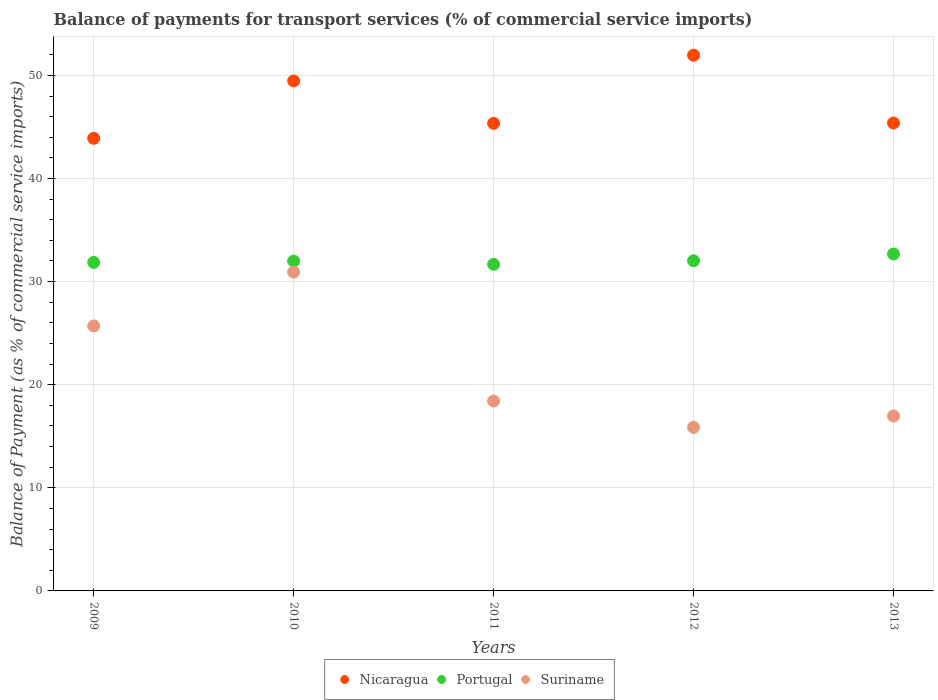What is the balance of payments for transport services in Portugal in 2013?
Provide a short and direct response. 32.68. Across all years, what is the maximum balance of payments for transport services in Suriname?
Your answer should be very brief. 30.92. Across all years, what is the minimum balance of payments for transport services in Portugal?
Your response must be concise. 31.68. In which year was the balance of payments for transport services in Portugal minimum?
Provide a succinct answer. 2011. What is the total balance of payments for transport services in Portugal in the graph?
Your answer should be very brief. 160.23. What is the difference between the balance of payments for transport services in Portugal in 2009 and that in 2012?
Offer a terse response. -0.16. What is the difference between the balance of payments for transport services in Portugal in 2010 and the balance of payments for transport services in Nicaragua in 2009?
Your response must be concise. -11.91. What is the average balance of payments for transport services in Portugal per year?
Your answer should be compact. 32.05. In the year 2013, what is the difference between the balance of payments for transport services in Portugal and balance of payments for transport services in Nicaragua?
Your answer should be compact. -12.7. What is the ratio of the balance of payments for transport services in Nicaragua in 2009 to that in 2013?
Offer a terse response. 0.97. Is the difference between the balance of payments for transport services in Portugal in 2012 and 2013 greater than the difference between the balance of payments for transport services in Nicaragua in 2012 and 2013?
Provide a short and direct response. No. What is the difference between the highest and the second highest balance of payments for transport services in Suriname?
Your response must be concise. 5.22. What is the difference between the highest and the lowest balance of payments for transport services in Portugal?
Offer a very short reply. 1. How many dotlines are there?
Provide a succinct answer. 3. Are the values on the major ticks of Y-axis written in scientific E-notation?
Give a very brief answer. No. Does the graph contain grids?
Ensure brevity in your answer.  Yes. Where does the legend appear in the graph?
Your answer should be compact. Bottom center. How many legend labels are there?
Give a very brief answer. 3. How are the legend labels stacked?
Provide a short and direct response. Horizontal. What is the title of the graph?
Provide a short and direct response. Balance of payments for transport services (% of commercial service imports). Does "Aruba" appear as one of the legend labels in the graph?
Make the answer very short. No. What is the label or title of the X-axis?
Make the answer very short. Years. What is the label or title of the Y-axis?
Your answer should be compact. Balance of Payment (as % of commercial service imports). What is the Balance of Payment (as % of commercial service imports) of Nicaragua in 2009?
Your answer should be very brief. 43.9. What is the Balance of Payment (as % of commercial service imports) of Portugal in 2009?
Ensure brevity in your answer.  31.86. What is the Balance of Payment (as % of commercial service imports) in Suriname in 2009?
Make the answer very short. 25.7. What is the Balance of Payment (as % of commercial service imports) in Nicaragua in 2010?
Keep it short and to the point. 49.46. What is the Balance of Payment (as % of commercial service imports) in Portugal in 2010?
Your response must be concise. 31.99. What is the Balance of Payment (as % of commercial service imports) of Suriname in 2010?
Make the answer very short. 30.92. What is the Balance of Payment (as % of commercial service imports) of Nicaragua in 2011?
Provide a succinct answer. 45.35. What is the Balance of Payment (as % of commercial service imports) in Portugal in 2011?
Your response must be concise. 31.68. What is the Balance of Payment (as % of commercial service imports) in Suriname in 2011?
Your answer should be compact. 18.42. What is the Balance of Payment (as % of commercial service imports) in Nicaragua in 2012?
Your answer should be very brief. 51.96. What is the Balance of Payment (as % of commercial service imports) in Portugal in 2012?
Ensure brevity in your answer.  32.02. What is the Balance of Payment (as % of commercial service imports) in Suriname in 2012?
Your response must be concise. 15.87. What is the Balance of Payment (as % of commercial service imports) of Nicaragua in 2013?
Provide a succinct answer. 45.38. What is the Balance of Payment (as % of commercial service imports) of Portugal in 2013?
Give a very brief answer. 32.68. What is the Balance of Payment (as % of commercial service imports) in Suriname in 2013?
Make the answer very short. 16.96. Across all years, what is the maximum Balance of Payment (as % of commercial service imports) of Nicaragua?
Ensure brevity in your answer.  51.96. Across all years, what is the maximum Balance of Payment (as % of commercial service imports) in Portugal?
Keep it short and to the point. 32.68. Across all years, what is the maximum Balance of Payment (as % of commercial service imports) in Suriname?
Keep it short and to the point. 30.92. Across all years, what is the minimum Balance of Payment (as % of commercial service imports) of Nicaragua?
Provide a succinct answer. 43.9. Across all years, what is the minimum Balance of Payment (as % of commercial service imports) in Portugal?
Keep it short and to the point. 31.68. Across all years, what is the minimum Balance of Payment (as % of commercial service imports) of Suriname?
Keep it short and to the point. 15.87. What is the total Balance of Payment (as % of commercial service imports) in Nicaragua in the graph?
Provide a succinct answer. 236.05. What is the total Balance of Payment (as % of commercial service imports) in Portugal in the graph?
Keep it short and to the point. 160.23. What is the total Balance of Payment (as % of commercial service imports) in Suriname in the graph?
Provide a succinct answer. 107.88. What is the difference between the Balance of Payment (as % of commercial service imports) in Nicaragua in 2009 and that in 2010?
Offer a very short reply. -5.57. What is the difference between the Balance of Payment (as % of commercial service imports) of Portugal in 2009 and that in 2010?
Give a very brief answer. -0.13. What is the difference between the Balance of Payment (as % of commercial service imports) of Suriname in 2009 and that in 2010?
Keep it short and to the point. -5.22. What is the difference between the Balance of Payment (as % of commercial service imports) of Nicaragua in 2009 and that in 2011?
Your response must be concise. -1.45. What is the difference between the Balance of Payment (as % of commercial service imports) of Portugal in 2009 and that in 2011?
Provide a succinct answer. 0.18. What is the difference between the Balance of Payment (as % of commercial service imports) of Suriname in 2009 and that in 2011?
Offer a terse response. 7.28. What is the difference between the Balance of Payment (as % of commercial service imports) of Nicaragua in 2009 and that in 2012?
Make the answer very short. -8.06. What is the difference between the Balance of Payment (as % of commercial service imports) in Portugal in 2009 and that in 2012?
Provide a short and direct response. -0.16. What is the difference between the Balance of Payment (as % of commercial service imports) in Suriname in 2009 and that in 2012?
Your answer should be very brief. 9.84. What is the difference between the Balance of Payment (as % of commercial service imports) of Nicaragua in 2009 and that in 2013?
Keep it short and to the point. -1.48. What is the difference between the Balance of Payment (as % of commercial service imports) of Portugal in 2009 and that in 2013?
Give a very brief answer. -0.82. What is the difference between the Balance of Payment (as % of commercial service imports) of Suriname in 2009 and that in 2013?
Give a very brief answer. 8.74. What is the difference between the Balance of Payment (as % of commercial service imports) in Nicaragua in 2010 and that in 2011?
Give a very brief answer. 4.11. What is the difference between the Balance of Payment (as % of commercial service imports) in Portugal in 2010 and that in 2011?
Offer a terse response. 0.31. What is the difference between the Balance of Payment (as % of commercial service imports) in Suriname in 2010 and that in 2011?
Ensure brevity in your answer.  12.5. What is the difference between the Balance of Payment (as % of commercial service imports) in Nicaragua in 2010 and that in 2012?
Offer a very short reply. -2.5. What is the difference between the Balance of Payment (as % of commercial service imports) in Portugal in 2010 and that in 2012?
Provide a succinct answer. -0.03. What is the difference between the Balance of Payment (as % of commercial service imports) of Suriname in 2010 and that in 2012?
Offer a very short reply. 15.06. What is the difference between the Balance of Payment (as % of commercial service imports) in Nicaragua in 2010 and that in 2013?
Give a very brief answer. 4.08. What is the difference between the Balance of Payment (as % of commercial service imports) of Portugal in 2010 and that in 2013?
Ensure brevity in your answer.  -0.69. What is the difference between the Balance of Payment (as % of commercial service imports) in Suriname in 2010 and that in 2013?
Provide a short and direct response. 13.96. What is the difference between the Balance of Payment (as % of commercial service imports) in Nicaragua in 2011 and that in 2012?
Your response must be concise. -6.61. What is the difference between the Balance of Payment (as % of commercial service imports) of Portugal in 2011 and that in 2012?
Give a very brief answer. -0.34. What is the difference between the Balance of Payment (as % of commercial service imports) in Suriname in 2011 and that in 2012?
Keep it short and to the point. 2.55. What is the difference between the Balance of Payment (as % of commercial service imports) in Nicaragua in 2011 and that in 2013?
Keep it short and to the point. -0.03. What is the difference between the Balance of Payment (as % of commercial service imports) in Portugal in 2011 and that in 2013?
Keep it short and to the point. -1. What is the difference between the Balance of Payment (as % of commercial service imports) of Suriname in 2011 and that in 2013?
Provide a succinct answer. 1.46. What is the difference between the Balance of Payment (as % of commercial service imports) in Nicaragua in 2012 and that in 2013?
Your answer should be very brief. 6.58. What is the difference between the Balance of Payment (as % of commercial service imports) in Portugal in 2012 and that in 2013?
Provide a short and direct response. -0.66. What is the difference between the Balance of Payment (as % of commercial service imports) in Suriname in 2012 and that in 2013?
Make the answer very short. -1.1. What is the difference between the Balance of Payment (as % of commercial service imports) in Nicaragua in 2009 and the Balance of Payment (as % of commercial service imports) in Portugal in 2010?
Your answer should be compact. 11.91. What is the difference between the Balance of Payment (as % of commercial service imports) in Nicaragua in 2009 and the Balance of Payment (as % of commercial service imports) in Suriname in 2010?
Make the answer very short. 12.97. What is the difference between the Balance of Payment (as % of commercial service imports) in Portugal in 2009 and the Balance of Payment (as % of commercial service imports) in Suriname in 2010?
Give a very brief answer. 0.94. What is the difference between the Balance of Payment (as % of commercial service imports) in Nicaragua in 2009 and the Balance of Payment (as % of commercial service imports) in Portugal in 2011?
Give a very brief answer. 12.22. What is the difference between the Balance of Payment (as % of commercial service imports) in Nicaragua in 2009 and the Balance of Payment (as % of commercial service imports) in Suriname in 2011?
Ensure brevity in your answer.  25.48. What is the difference between the Balance of Payment (as % of commercial service imports) of Portugal in 2009 and the Balance of Payment (as % of commercial service imports) of Suriname in 2011?
Provide a succinct answer. 13.44. What is the difference between the Balance of Payment (as % of commercial service imports) in Nicaragua in 2009 and the Balance of Payment (as % of commercial service imports) in Portugal in 2012?
Provide a short and direct response. 11.88. What is the difference between the Balance of Payment (as % of commercial service imports) in Nicaragua in 2009 and the Balance of Payment (as % of commercial service imports) in Suriname in 2012?
Provide a short and direct response. 28.03. What is the difference between the Balance of Payment (as % of commercial service imports) of Portugal in 2009 and the Balance of Payment (as % of commercial service imports) of Suriname in 2012?
Offer a very short reply. 16. What is the difference between the Balance of Payment (as % of commercial service imports) of Nicaragua in 2009 and the Balance of Payment (as % of commercial service imports) of Portugal in 2013?
Keep it short and to the point. 11.22. What is the difference between the Balance of Payment (as % of commercial service imports) of Nicaragua in 2009 and the Balance of Payment (as % of commercial service imports) of Suriname in 2013?
Your answer should be very brief. 26.93. What is the difference between the Balance of Payment (as % of commercial service imports) of Portugal in 2009 and the Balance of Payment (as % of commercial service imports) of Suriname in 2013?
Keep it short and to the point. 14.9. What is the difference between the Balance of Payment (as % of commercial service imports) in Nicaragua in 2010 and the Balance of Payment (as % of commercial service imports) in Portugal in 2011?
Provide a short and direct response. 17.79. What is the difference between the Balance of Payment (as % of commercial service imports) of Nicaragua in 2010 and the Balance of Payment (as % of commercial service imports) of Suriname in 2011?
Offer a terse response. 31.04. What is the difference between the Balance of Payment (as % of commercial service imports) of Portugal in 2010 and the Balance of Payment (as % of commercial service imports) of Suriname in 2011?
Ensure brevity in your answer.  13.57. What is the difference between the Balance of Payment (as % of commercial service imports) of Nicaragua in 2010 and the Balance of Payment (as % of commercial service imports) of Portugal in 2012?
Provide a short and direct response. 17.44. What is the difference between the Balance of Payment (as % of commercial service imports) of Nicaragua in 2010 and the Balance of Payment (as % of commercial service imports) of Suriname in 2012?
Your response must be concise. 33.6. What is the difference between the Balance of Payment (as % of commercial service imports) of Portugal in 2010 and the Balance of Payment (as % of commercial service imports) of Suriname in 2012?
Offer a very short reply. 16.12. What is the difference between the Balance of Payment (as % of commercial service imports) of Nicaragua in 2010 and the Balance of Payment (as % of commercial service imports) of Portugal in 2013?
Your answer should be compact. 16.79. What is the difference between the Balance of Payment (as % of commercial service imports) in Nicaragua in 2010 and the Balance of Payment (as % of commercial service imports) in Suriname in 2013?
Ensure brevity in your answer.  32.5. What is the difference between the Balance of Payment (as % of commercial service imports) of Portugal in 2010 and the Balance of Payment (as % of commercial service imports) of Suriname in 2013?
Offer a terse response. 15.02. What is the difference between the Balance of Payment (as % of commercial service imports) of Nicaragua in 2011 and the Balance of Payment (as % of commercial service imports) of Portugal in 2012?
Offer a terse response. 13.33. What is the difference between the Balance of Payment (as % of commercial service imports) of Nicaragua in 2011 and the Balance of Payment (as % of commercial service imports) of Suriname in 2012?
Give a very brief answer. 29.48. What is the difference between the Balance of Payment (as % of commercial service imports) in Portugal in 2011 and the Balance of Payment (as % of commercial service imports) in Suriname in 2012?
Provide a succinct answer. 15.81. What is the difference between the Balance of Payment (as % of commercial service imports) in Nicaragua in 2011 and the Balance of Payment (as % of commercial service imports) in Portugal in 2013?
Your answer should be compact. 12.67. What is the difference between the Balance of Payment (as % of commercial service imports) of Nicaragua in 2011 and the Balance of Payment (as % of commercial service imports) of Suriname in 2013?
Your answer should be very brief. 28.38. What is the difference between the Balance of Payment (as % of commercial service imports) in Portugal in 2011 and the Balance of Payment (as % of commercial service imports) in Suriname in 2013?
Your answer should be very brief. 14.71. What is the difference between the Balance of Payment (as % of commercial service imports) of Nicaragua in 2012 and the Balance of Payment (as % of commercial service imports) of Portugal in 2013?
Ensure brevity in your answer.  19.28. What is the difference between the Balance of Payment (as % of commercial service imports) in Nicaragua in 2012 and the Balance of Payment (as % of commercial service imports) in Suriname in 2013?
Give a very brief answer. 35. What is the difference between the Balance of Payment (as % of commercial service imports) of Portugal in 2012 and the Balance of Payment (as % of commercial service imports) of Suriname in 2013?
Provide a succinct answer. 15.05. What is the average Balance of Payment (as % of commercial service imports) of Nicaragua per year?
Your answer should be very brief. 47.21. What is the average Balance of Payment (as % of commercial service imports) of Portugal per year?
Your answer should be compact. 32.05. What is the average Balance of Payment (as % of commercial service imports) in Suriname per year?
Provide a succinct answer. 21.58. In the year 2009, what is the difference between the Balance of Payment (as % of commercial service imports) in Nicaragua and Balance of Payment (as % of commercial service imports) in Portugal?
Ensure brevity in your answer.  12.04. In the year 2009, what is the difference between the Balance of Payment (as % of commercial service imports) of Nicaragua and Balance of Payment (as % of commercial service imports) of Suriname?
Provide a short and direct response. 18.2. In the year 2009, what is the difference between the Balance of Payment (as % of commercial service imports) in Portugal and Balance of Payment (as % of commercial service imports) in Suriname?
Make the answer very short. 6.16. In the year 2010, what is the difference between the Balance of Payment (as % of commercial service imports) in Nicaragua and Balance of Payment (as % of commercial service imports) in Portugal?
Your response must be concise. 17.48. In the year 2010, what is the difference between the Balance of Payment (as % of commercial service imports) in Nicaragua and Balance of Payment (as % of commercial service imports) in Suriname?
Provide a succinct answer. 18.54. In the year 2010, what is the difference between the Balance of Payment (as % of commercial service imports) of Portugal and Balance of Payment (as % of commercial service imports) of Suriname?
Your answer should be compact. 1.06. In the year 2011, what is the difference between the Balance of Payment (as % of commercial service imports) in Nicaragua and Balance of Payment (as % of commercial service imports) in Portugal?
Offer a terse response. 13.67. In the year 2011, what is the difference between the Balance of Payment (as % of commercial service imports) of Nicaragua and Balance of Payment (as % of commercial service imports) of Suriname?
Give a very brief answer. 26.93. In the year 2011, what is the difference between the Balance of Payment (as % of commercial service imports) of Portugal and Balance of Payment (as % of commercial service imports) of Suriname?
Your answer should be very brief. 13.26. In the year 2012, what is the difference between the Balance of Payment (as % of commercial service imports) in Nicaragua and Balance of Payment (as % of commercial service imports) in Portugal?
Make the answer very short. 19.94. In the year 2012, what is the difference between the Balance of Payment (as % of commercial service imports) in Nicaragua and Balance of Payment (as % of commercial service imports) in Suriname?
Keep it short and to the point. 36.09. In the year 2012, what is the difference between the Balance of Payment (as % of commercial service imports) in Portugal and Balance of Payment (as % of commercial service imports) in Suriname?
Ensure brevity in your answer.  16.15. In the year 2013, what is the difference between the Balance of Payment (as % of commercial service imports) of Nicaragua and Balance of Payment (as % of commercial service imports) of Portugal?
Provide a short and direct response. 12.7. In the year 2013, what is the difference between the Balance of Payment (as % of commercial service imports) in Nicaragua and Balance of Payment (as % of commercial service imports) in Suriname?
Make the answer very short. 28.42. In the year 2013, what is the difference between the Balance of Payment (as % of commercial service imports) of Portugal and Balance of Payment (as % of commercial service imports) of Suriname?
Keep it short and to the point. 15.71. What is the ratio of the Balance of Payment (as % of commercial service imports) in Nicaragua in 2009 to that in 2010?
Provide a succinct answer. 0.89. What is the ratio of the Balance of Payment (as % of commercial service imports) in Portugal in 2009 to that in 2010?
Give a very brief answer. 1. What is the ratio of the Balance of Payment (as % of commercial service imports) in Suriname in 2009 to that in 2010?
Give a very brief answer. 0.83. What is the ratio of the Balance of Payment (as % of commercial service imports) of Suriname in 2009 to that in 2011?
Offer a very short reply. 1.4. What is the ratio of the Balance of Payment (as % of commercial service imports) of Nicaragua in 2009 to that in 2012?
Offer a terse response. 0.84. What is the ratio of the Balance of Payment (as % of commercial service imports) in Suriname in 2009 to that in 2012?
Provide a succinct answer. 1.62. What is the ratio of the Balance of Payment (as % of commercial service imports) of Nicaragua in 2009 to that in 2013?
Ensure brevity in your answer.  0.97. What is the ratio of the Balance of Payment (as % of commercial service imports) of Suriname in 2009 to that in 2013?
Offer a very short reply. 1.51. What is the ratio of the Balance of Payment (as % of commercial service imports) in Nicaragua in 2010 to that in 2011?
Ensure brevity in your answer.  1.09. What is the ratio of the Balance of Payment (as % of commercial service imports) in Portugal in 2010 to that in 2011?
Your response must be concise. 1.01. What is the ratio of the Balance of Payment (as % of commercial service imports) in Suriname in 2010 to that in 2011?
Provide a short and direct response. 1.68. What is the ratio of the Balance of Payment (as % of commercial service imports) in Nicaragua in 2010 to that in 2012?
Ensure brevity in your answer.  0.95. What is the ratio of the Balance of Payment (as % of commercial service imports) in Suriname in 2010 to that in 2012?
Provide a succinct answer. 1.95. What is the ratio of the Balance of Payment (as % of commercial service imports) of Nicaragua in 2010 to that in 2013?
Offer a terse response. 1.09. What is the ratio of the Balance of Payment (as % of commercial service imports) in Portugal in 2010 to that in 2013?
Provide a succinct answer. 0.98. What is the ratio of the Balance of Payment (as % of commercial service imports) in Suriname in 2010 to that in 2013?
Your response must be concise. 1.82. What is the ratio of the Balance of Payment (as % of commercial service imports) of Nicaragua in 2011 to that in 2012?
Ensure brevity in your answer.  0.87. What is the ratio of the Balance of Payment (as % of commercial service imports) of Portugal in 2011 to that in 2012?
Provide a short and direct response. 0.99. What is the ratio of the Balance of Payment (as % of commercial service imports) of Suriname in 2011 to that in 2012?
Your answer should be compact. 1.16. What is the ratio of the Balance of Payment (as % of commercial service imports) in Portugal in 2011 to that in 2013?
Give a very brief answer. 0.97. What is the ratio of the Balance of Payment (as % of commercial service imports) of Suriname in 2011 to that in 2013?
Make the answer very short. 1.09. What is the ratio of the Balance of Payment (as % of commercial service imports) in Nicaragua in 2012 to that in 2013?
Your response must be concise. 1.15. What is the ratio of the Balance of Payment (as % of commercial service imports) of Portugal in 2012 to that in 2013?
Ensure brevity in your answer.  0.98. What is the ratio of the Balance of Payment (as % of commercial service imports) in Suriname in 2012 to that in 2013?
Your answer should be compact. 0.94. What is the difference between the highest and the second highest Balance of Payment (as % of commercial service imports) in Nicaragua?
Provide a succinct answer. 2.5. What is the difference between the highest and the second highest Balance of Payment (as % of commercial service imports) of Portugal?
Keep it short and to the point. 0.66. What is the difference between the highest and the second highest Balance of Payment (as % of commercial service imports) of Suriname?
Make the answer very short. 5.22. What is the difference between the highest and the lowest Balance of Payment (as % of commercial service imports) of Nicaragua?
Your response must be concise. 8.06. What is the difference between the highest and the lowest Balance of Payment (as % of commercial service imports) in Portugal?
Give a very brief answer. 1. What is the difference between the highest and the lowest Balance of Payment (as % of commercial service imports) in Suriname?
Ensure brevity in your answer.  15.06. 